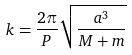Convert formula to latex. <formula><loc_0><loc_0><loc_500><loc_500>k = \frac { 2 \pi } { P } \sqrt { \frac { a ^ { 3 } } { M + m } }</formula> 